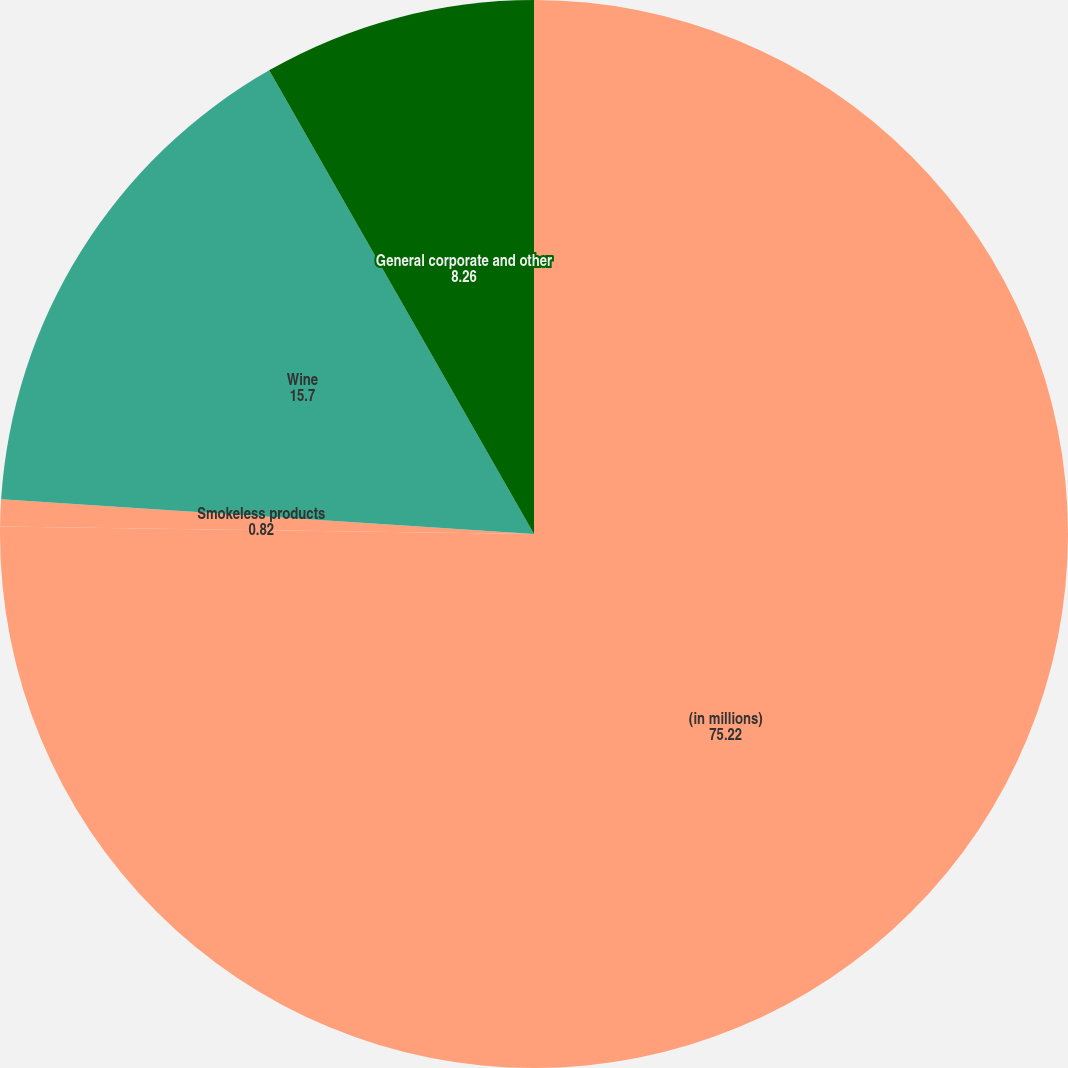<chart> <loc_0><loc_0><loc_500><loc_500><pie_chart><fcel>(in millions)<fcel>Smokeless products<fcel>Wine<fcel>General corporate and other<nl><fcel>75.22%<fcel>0.82%<fcel>15.7%<fcel>8.26%<nl></chart> 